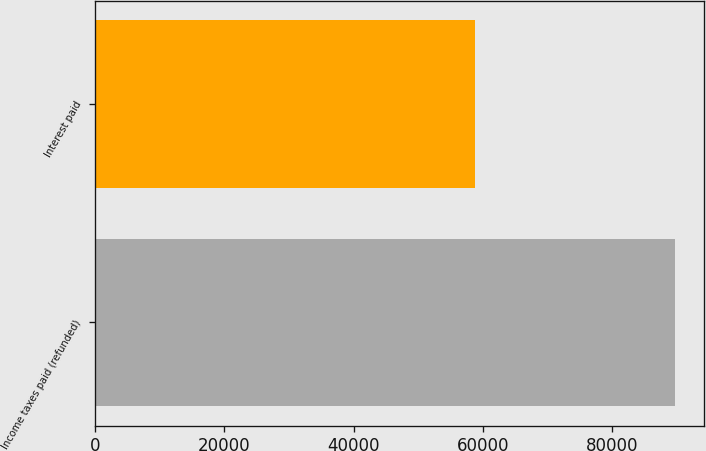Convert chart. <chart><loc_0><loc_0><loc_500><loc_500><bar_chart><fcel>Income taxes paid (refunded)<fcel>Interest paid<nl><fcel>89684<fcel>58730<nl></chart> 